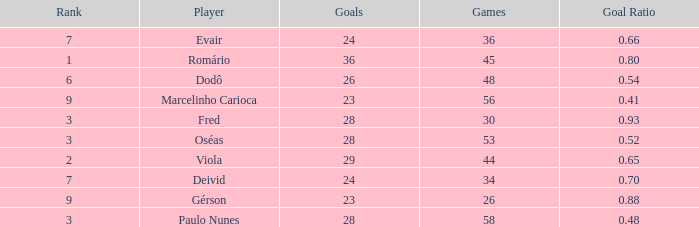How many games have 23 goals with a rank greater than 9? 0.0. 